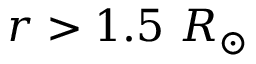<formula> <loc_0><loc_0><loc_500><loc_500>r > 1 . 5 \ R _ { \odot }</formula> 